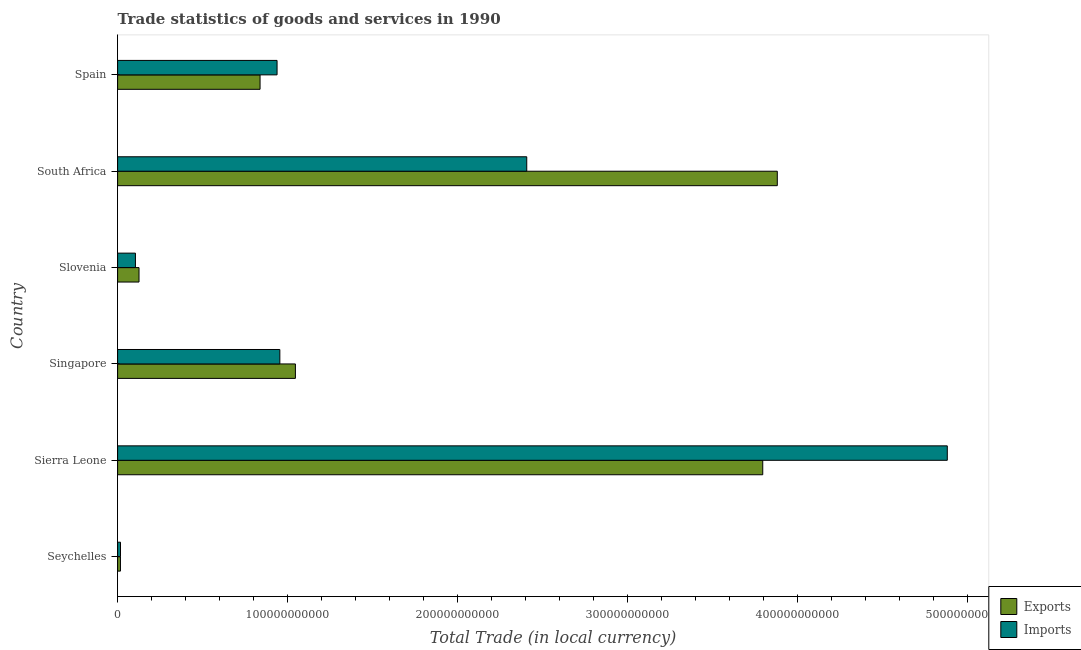How many groups of bars are there?
Provide a succinct answer. 6. How many bars are there on the 6th tick from the top?
Offer a very short reply. 2. What is the label of the 6th group of bars from the top?
Offer a terse response. Seychelles. In how many cases, is the number of bars for a given country not equal to the number of legend labels?
Provide a short and direct response. 0. What is the imports of goods and services in Singapore?
Offer a terse response. 9.55e+1. Across all countries, what is the maximum export of goods and services?
Offer a terse response. 3.88e+11. Across all countries, what is the minimum export of goods and services?
Your answer should be compact. 1.67e+09. In which country was the export of goods and services maximum?
Provide a succinct answer. South Africa. In which country was the export of goods and services minimum?
Your response must be concise. Seychelles. What is the total imports of goods and services in the graph?
Give a very brief answer. 9.31e+11. What is the difference between the imports of goods and services in Seychelles and that in Sierra Leone?
Your answer should be compact. -4.87e+11. What is the difference between the export of goods and services in South Africa and the imports of goods and services in Spain?
Give a very brief answer. 2.94e+11. What is the average imports of goods and services per country?
Give a very brief answer. 1.55e+11. What is the difference between the export of goods and services and imports of goods and services in Spain?
Give a very brief answer. -1.00e+1. What is the ratio of the export of goods and services in Sierra Leone to that in Spain?
Keep it short and to the point. 4.53. Is the difference between the imports of goods and services in Sierra Leone and South Africa greater than the difference between the export of goods and services in Sierra Leone and South Africa?
Your answer should be very brief. Yes. What is the difference between the highest and the second highest export of goods and services?
Your answer should be compact. 8.56e+09. What is the difference between the highest and the lowest export of goods and services?
Offer a terse response. 3.87e+11. What does the 1st bar from the top in Singapore represents?
Make the answer very short. Imports. What does the 1st bar from the bottom in Sierra Leone represents?
Offer a terse response. Exports. How many countries are there in the graph?
Your answer should be very brief. 6. What is the difference between two consecutive major ticks on the X-axis?
Your response must be concise. 1.00e+11. Does the graph contain grids?
Your answer should be compact. No. How many legend labels are there?
Your answer should be very brief. 2. How are the legend labels stacked?
Provide a succinct answer. Vertical. What is the title of the graph?
Offer a terse response. Trade statistics of goods and services in 1990. Does "Boys" appear as one of the legend labels in the graph?
Your answer should be very brief. No. What is the label or title of the X-axis?
Provide a succinct answer. Total Trade (in local currency). What is the Total Trade (in local currency) in Exports in Seychelles?
Make the answer very short. 1.67e+09. What is the Total Trade (in local currency) of Imports in Seychelles?
Give a very brief answer. 1.70e+09. What is the Total Trade (in local currency) in Exports in Sierra Leone?
Ensure brevity in your answer.  3.80e+11. What is the Total Trade (in local currency) of Imports in Sierra Leone?
Make the answer very short. 4.88e+11. What is the Total Trade (in local currency) in Exports in Singapore?
Your answer should be compact. 1.05e+11. What is the Total Trade (in local currency) of Imports in Singapore?
Provide a succinct answer. 9.55e+1. What is the Total Trade (in local currency) of Exports in Slovenia?
Offer a very short reply. 1.26e+1. What is the Total Trade (in local currency) of Imports in Slovenia?
Your answer should be very brief. 1.05e+1. What is the Total Trade (in local currency) in Exports in South Africa?
Offer a very short reply. 3.88e+11. What is the Total Trade (in local currency) of Imports in South Africa?
Your response must be concise. 2.41e+11. What is the Total Trade (in local currency) of Exports in Spain?
Offer a terse response. 8.38e+1. What is the Total Trade (in local currency) in Imports in Spain?
Provide a short and direct response. 9.39e+1. Across all countries, what is the maximum Total Trade (in local currency) of Exports?
Your response must be concise. 3.88e+11. Across all countries, what is the maximum Total Trade (in local currency) of Imports?
Ensure brevity in your answer.  4.88e+11. Across all countries, what is the minimum Total Trade (in local currency) in Exports?
Ensure brevity in your answer.  1.67e+09. Across all countries, what is the minimum Total Trade (in local currency) of Imports?
Keep it short and to the point. 1.70e+09. What is the total Total Trade (in local currency) in Exports in the graph?
Your answer should be compact. 9.71e+11. What is the total Total Trade (in local currency) of Imports in the graph?
Offer a terse response. 9.31e+11. What is the difference between the Total Trade (in local currency) of Exports in Seychelles and that in Sierra Leone?
Your response must be concise. -3.78e+11. What is the difference between the Total Trade (in local currency) of Imports in Seychelles and that in Sierra Leone?
Provide a short and direct response. -4.87e+11. What is the difference between the Total Trade (in local currency) of Exports in Seychelles and that in Singapore?
Make the answer very short. -1.03e+11. What is the difference between the Total Trade (in local currency) of Imports in Seychelles and that in Singapore?
Your response must be concise. -9.38e+1. What is the difference between the Total Trade (in local currency) of Exports in Seychelles and that in Slovenia?
Offer a very short reply. -1.09e+1. What is the difference between the Total Trade (in local currency) of Imports in Seychelles and that in Slovenia?
Ensure brevity in your answer.  -8.79e+09. What is the difference between the Total Trade (in local currency) of Exports in Seychelles and that in South Africa?
Provide a succinct answer. -3.87e+11. What is the difference between the Total Trade (in local currency) of Imports in Seychelles and that in South Africa?
Your response must be concise. -2.39e+11. What is the difference between the Total Trade (in local currency) of Exports in Seychelles and that in Spain?
Give a very brief answer. -8.22e+1. What is the difference between the Total Trade (in local currency) in Imports in Seychelles and that in Spain?
Your answer should be very brief. -9.22e+1. What is the difference between the Total Trade (in local currency) in Exports in Sierra Leone and that in Singapore?
Ensure brevity in your answer.  2.75e+11. What is the difference between the Total Trade (in local currency) of Imports in Sierra Leone and that in Singapore?
Give a very brief answer. 3.93e+11. What is the difference between the Total Trade (in local currency) in Exports in Sierra Leone and that in Slovenia?
Your answer should be compact. 3.67e+11. What is the difference between the Total Trade (in local currency) of Imports in Sierra Leone and that in Slovenia?
Offer a terse response. 4.78e+11. What is the difference between the Total Trade (in local currency) in Exports in Sierra Leone and that in South Africa?
Make the answer very short. -8.56e+09. What is the difference between the Total Trade (in local currency) in Imports in Sierra Leone and that in South Africa?
Provide a short and direct response. 2.48e+11. What is the difference between the Total Trade (in local currency) in Exports in Sierra Leone and that in Spain?
Keep it short and to the point. 2.96e+11. What is the difference between the Total Trade (in local currency) of Imports in Sierra Leone and that in Spain?
Ensure brevity in your answer.  3.94e+11. What is the difference between the Total Trade (in local currency) in Exports in Singapore and that in Slovenia?
Your response must be concise. 9.20e+1. What is the difference between the Total Trade (in local currency) in Imports in Singapore and that in Slovenia?
Your answer should be compact. 8.50e+1. What is the difference between the Total Trade (in local currency) in Exports in Singapore and that in South Africa?
Your answer should be compact. -2.84e+11. What is the difference between the Total Trade (in local currency) in Imports in Singapore and that in South Africa?
Ensure brevity in your answer.  -1.45e+11. What is the difference between the Total Trade (in local currency) of Exports in Singapore and that in Spain?
Make the answer very short. 2.08e+1. What is the difference between the Total Trade (in local currency) in Imports in Singapore and that in Spain?
Provide a succinct answer. 1.63e+09. What is the difference between the Total Trade (in local currency) in Exports in Slovenia and that in South Africa?
Offer a very short reply. -3.76e+11. What is the difference between the Total Trade (in local currency) in Imports in Slovenia and that in South Africa?
Your response must be concise. -2.30e+11. What is the difference between the Total Trade (in local currency) in Exports in Slovenia and that in Spain?
Provide a short and direct response. -7.12e+1. What is the difference between the Total Trade (in local currency) in Imports in Slovenia and that in Spain?
Your answer should be very brief. -8.34e+1. What is the difference between the Total Trade (in local currency) in Exports in South Africa and that in Spain?
Your answer should be compact. 3.04e+11. What is the difference between the Total Trade (in local currency) in Imports in South Africa and that in Spain?
Offer a very short reply. 1.47e+11. What is the difference between the Total Trade (in local currency) of Exports in Seychelles and the Total Trade (in local currency) of Imports in Sierra Leone?
Make the answer very short. -4.87e+11. What is the difference between the Total Trade (in local currency) of Exports in Seychelles and the Total Trade (in local currency) of Imports in Singapore?
Offer a very short reply. -9.38e+1. What is the difference between the Total Trade (in local currency) in Exports in Seychelles and the Total Trade (in local currency) in Imports in Slovenia?
Give a very brief answer. -8.82e+09. What is the difference between the Total Trade (in local currency) in Exports in Seychelles and the Total Trade (in local currency) in Imports in South Africa?
Your answer should be very brief. -2.39e+11. What is the difference between the Total Trade (in local currency) of Exports in Seychelles and the Total Trade (in local currency) of Imports in Spain?
Make the answer very short. -9.22e+1. What is the difference between the Total Trade (in local currency) of Exports in Sierra Leone and the Total Trade (in local currency) of Imports in Singapore?
Your answer should be compact. 2.84e+11. What is the difference between the Total Trade (in local currency) in Exports in Sierra Leone and the Total Trade (in local currency) in Imports in Slovenia?
Your answer should be very brief. 3.69e+11. What is the difference between the Total Trade (in local currency) in Exports in Sierra Leone and the Total Trade (in local currency) in Imports in South Africa?
Your answer should be very brief. 1.39e+11. What is the difference between the Total Trade (in local currency) in Exports in Sierra Leone and the Total Trade (in local currency) in Imports in Spain?
Give a very brief answer. 2.86e+11. What is the difference between the Total Trade (in local currency) in Exports in Singapore and the Total Trade (in local currency) in Imports in Slovenia?
Make the answer very short. 9.42e+1. What is the difference between the Total Trade (in local currency) of Exports in Singapore and the Total Trade (in local currency) of Imports in South Africa?
Make the answer very short. -1.36e+11. What is the difference between the Total Trade (in local currency) in Exports in Singapore and the Total Trade (in local currency) in Imports in Spain?
Ensure brevity in your answer.  1.08e+1. What is the difference between the Total Trade (in local currency) in Exports in Slovenia and the Total Trade (in local currency) in Imports in South Africa?
Keep it short and to the point. -2.28e+11. What is the difference between the Total Trade (in local currency) in Exports in Slovenia and the Total Trade (in local currency) in Imports in Spain?
Make the answer very short. -8.13e+1. What is the difference between the Total Trade (in local currency) of Exports in South Africa and the Total Trade (in local currency) of Imports in Spain?
Your answer should be very brief. 2.94e+11. What is the average Total Trade (in local currency) of Exports per country?
Make the answer very short. 1.62e+11. What is the average Total Trade (in local currency) in Imports per country?
Keep it short and to the point. 1.55e+11. What is the difference between the Total Trade (in local currency) in Exports and Total Trade (in local currency) in Imports in Seychelles?
Your answer should be very brief. -3.23e+07. What is the difference between the Total Trade (in local currency) in Exports and Total Trade (in local currency) in Imports in Sierra Leone?
Your answer should be compact. -1.09e+11. What is the difference between the Total Trade (in local currency) of Exports and Total Trade (in local currency) of Imports in Singapore?
Your answer should be very brief. 9.16e+09. What is the difference between the Total Trade (in local currency) of Exports and Total Trade (in local currency) of Imports in Slovenia?
Your response must be concise. 2.11e+09. What is the difference between the Total Trade (in local currency) of Exports and Total Trade (in local currency) of Imports in South Africa?
Offer a terse response. 1.47e+11. What is the difference between the Total Trade (in local currency) in Exports and Total Trade (in local currency) in Imports in Spain?
Give a very brief answer. -1.00e+1. What is the ratio of the Total Trade (in local currency) in Exports in Seychelles to that in Sierra Leone?
Offer a terse response. 0. What is the ratio of the Total Trade (in local currency) of Imports in Seychelles to that in Sierra Leone?
Your answer should be compact. 0. What is the ratio of the Total Trade (in local currency) in Exports in Seychelles to that in Singapore?
Offer a very short reply. 0.02. What is the ratio of the Total Trade (in local currency) of Imports in Seychelles to that in Singapore?
Your answer should be compact. 0.02. What is the ratio of the Total Trade (in local currency) of Exports in Seychelles to that in Slovenia?
Keep it short and to the point. 0.13. What is the ratio of the Total Trade (in local currency) of Imports in Seychelles to that in Slovenia?
Provide a short and direct response. 0.16. What is the ratio of the Total Trade (in local currency) of Exports in Seychelles to that in South Africa?
Your answer should be compact. 0. What is the ratio of the Total Trade (in local currency) of Imports in Seychelles to that in South Africa?
Your answer should be very brief. 0.01. What is the ratio of the Total Trade (in local currency) of Exports in Seychelles to that in Spain?
Your answer should be compact. 0.02. What is the ratio of the Total Trade (in local currency) in Imports in Seychelles to that in Spain?
Keep it short and to the point. 0.02. What is the ratio of the Total Trade (in local currency) in Exports in Sierra Leone to that in Singapore?
Provide a succinct answer. 3.63. What is the ratio of the Total Trade (in local currency) in Imports in Sierra Leone to that in Singapore?
Provide a short and direct response. 5.11. What is the ratio of the Total Trade (in local currency) in Exports in Sierra Leone to that in Slovenia?
Keep it short and to the point. 30.13. What is the ratio of the Total Trade (in local currency) of Imports in Sierra Leone to that in Slovenia?
Offer a very short reply. 46.53. What is the ratio of the Total Trade (in local currency) of Imports in Sierra Leone to that in South Africa?
Your answer should be very brief. 2.03. What is the ratio of the Total Trade (in local currency) in Exports in Sierra Leone to that in Spain?
Ensure brevity in your answer.  4.53. What is the ratio of the Total Trade (in local currency) in Imports in Sierra Leone to that in Spain?
Keep it short and to the point. 5.2. What is the ratio of the Total Trade (in local currency) of Exports in Singapore to that in Slovenia?
Provide a short and direct response. 8.3. What is the ratio of the Total Trade (in local currency) of Imports in Singapore to that in Slovenia?
Offer a very short reply. 9.1. What is the ratio of the Total Trade (in local currency) of Exports in Singapore to that in South Africa?
Your response must be concise. 0.27. What is the ratio of the Total Trade (in local currency) in Imports in Singapore to that in South Africa?
Give a very brief answer. 0.4. What is the ratio of the Total Trade (in local currency) in Exports in Singapore to that in Spain?
Your answer should be compact. 1.25. What is the ratio of the Total Trade (in local currency) in Imports in Singapore to that in Spain?
Offer a terse response. 1.02. What is the ratio of the Total Trade (in local currency) of Exports in Slovenia to that in South Africa?
Give a very brief answer. 0.03. What is the ratio of the Total Trade (in local currency) of Imports in Slovenia to that in South Africa?
Ensure brevity in your answer.  0.04. What is the ratio of the Total Trade (in local currency) in Exports in Slovenia to that in Spain?
Your response must be concise. 0.15. What is the ratio of the Total Trade (in local currency) in Imports in Slovenia to that in Spain?
Provide a succinct answer. 0.11. What is the ratio of the Total Trade (in local currency) in Exports in South Africa to that in Spain?
Ensure brevity in your answer.  4.63. What is the ratio of the Total Trade (in local currency) of Imports in South Africa to that in Spain?
Your answer should be compact. 2.57. What is the difference between the highest and the second highest Total Trade (in local currency) of Exports?
Your answer should be compact. 8.56e+09. What is the difference between the highest and the second highest Total Trade (in local currency) of Imports?
Offer a very short reply. 2.48e+11. What is the difference between the highest and the lowest Total Trade (in local currency) in Exports?
Provide a short and direct response. 3.87e+11. What is the difference between the highest and the lowest Total Trade (in local currency) of Imports?
Your response must be concise. 4.87e+11. 